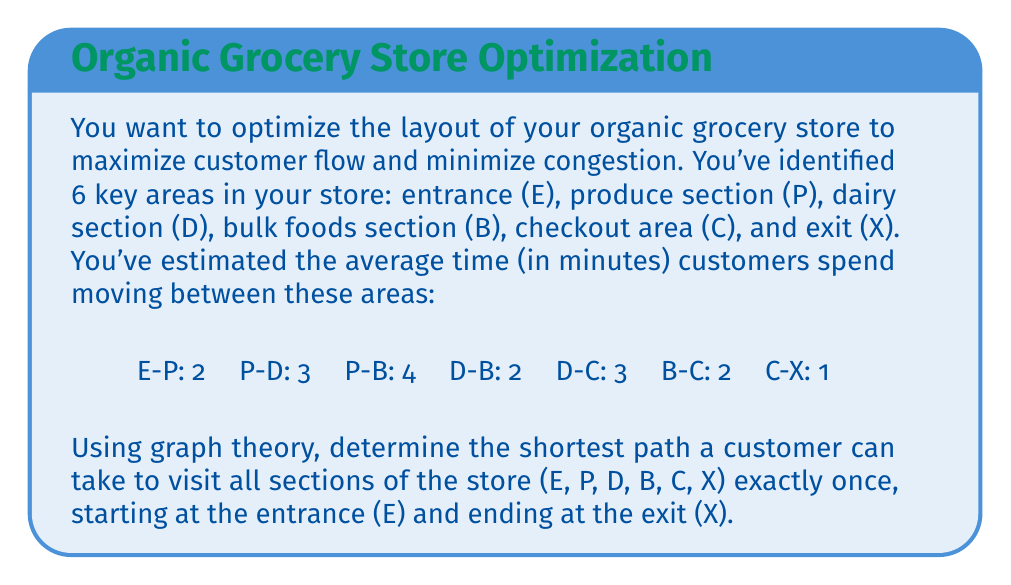Solve this math problem. To solve this problem, we can use the concept of the Traveling Salesman Problem (TSP) from graph theory, adapted to our specific store layout scenario. Here's how we can approach this:

1) First, let's represent our store as a graph:
   - Vertices: E, P, D, B, C, X
   - Edges: The paths between sections with their corresponding times

2) We need to find the Hamiltonian path (a path that visits each vertex exactly once) from E to X that minimizes the total time.

3) Given the small number of vertices, we can solve this by considering all possible paths and calculating their total times. The possible paths are:

   E -> P -> D -> B -> C -> X
   E -> P -> B -> D -> C -> X

4) Let's calculate the time for each path:

   Path 1: E -> P -> D -> B -> C -> X
   Time = 2 + 3 + 2 + 2 + 1 = 10 minutes

   Path 2: E -> P -> B -> D -> C -> X
   Time = 2 + 4 + 2 + 3 + 1 = 12 minutes

5) The shortest path is Path 1: E -> P -> D -> B -> C -> X, with a total time of 10 minutes.

This layout ensures that customers can efficiently visit all sections of the store in the shortest possible time, potentially increasing customer satisfaction and store throughput.
Answer: The shortest path for a customer to visit all sections of the store exactly once is:

E -> P -> D -> B -> C -> X

Total time: 10 minutes 